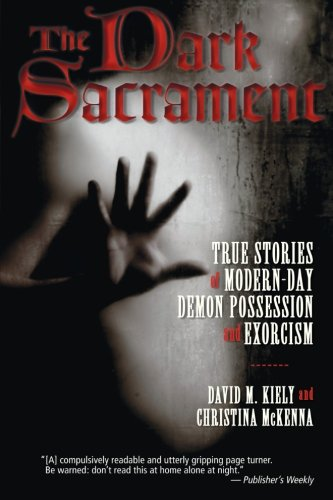What is the significance of the image on the cover? The cover features a haunting image that likely symbolizes the themes of possession and spirituality discussed in the book, designed to evoke a sense of fear and intrigue. 